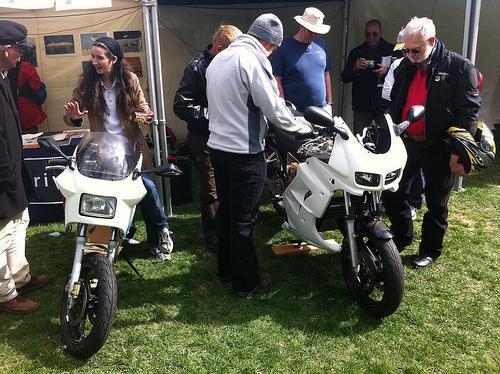How many bikes?
Give a very brief answer. 2. 